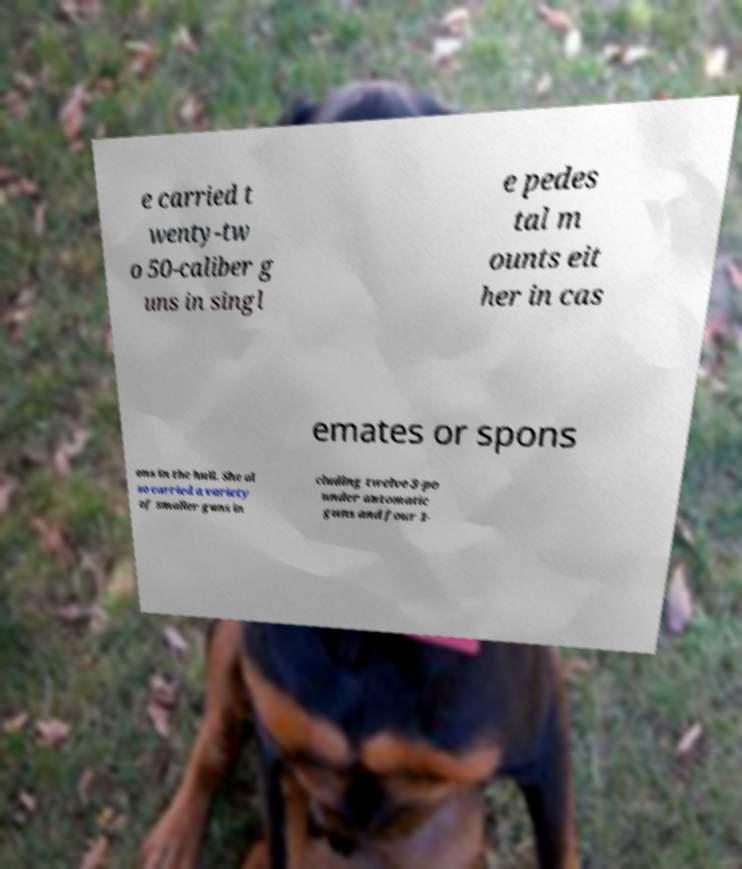Please read and relay the text visible in this image. What does it say? e carried t wenty-tw o 50-caliber g uns in singl e pedes tal m ounts eit her in cas emates or spons ons in the hull. She al so carried a variety of smaller guns in cluding twelve 3-po under automatic guns and four 1- 